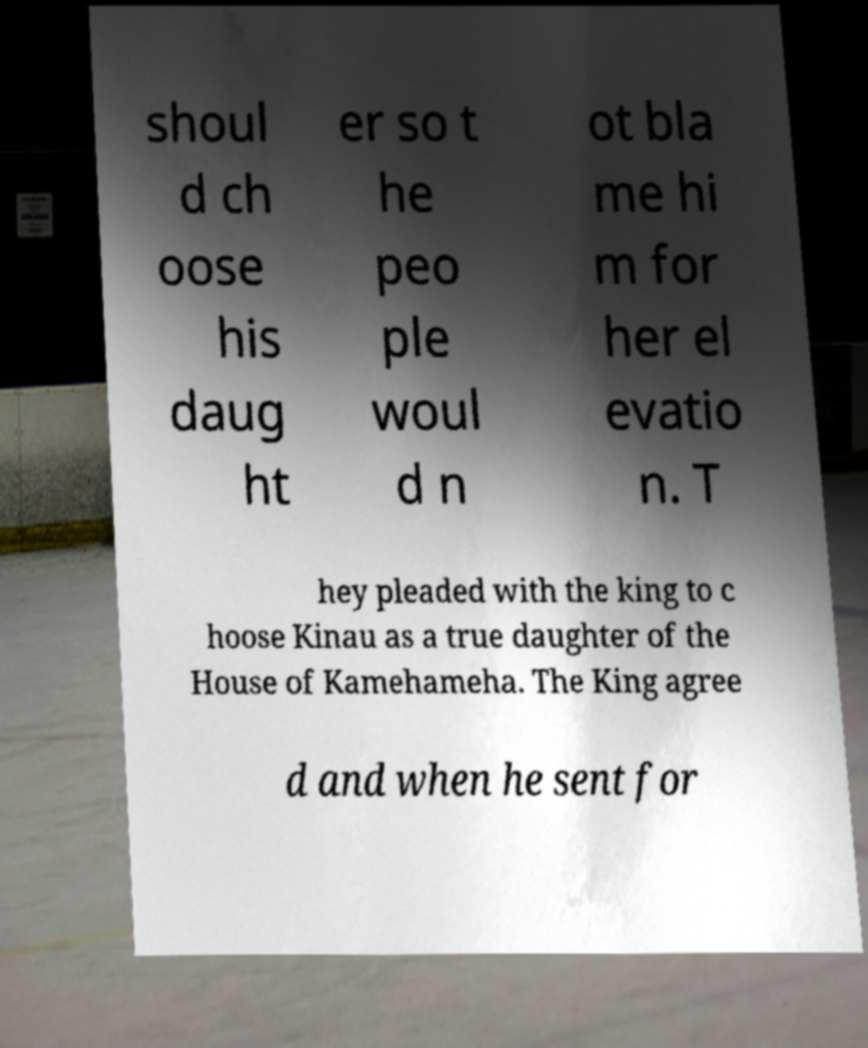What messages or text are displayed in this image? I need them in a readable, typed format. shoul d ch oose his daug ht er so t he peo ple woul d n ot bla me hi m for her el evatio n. T hey pleaded with the king to c hoose Kinau as a true daughter of the House of Kamehameha. The King agree d and when he sent for 